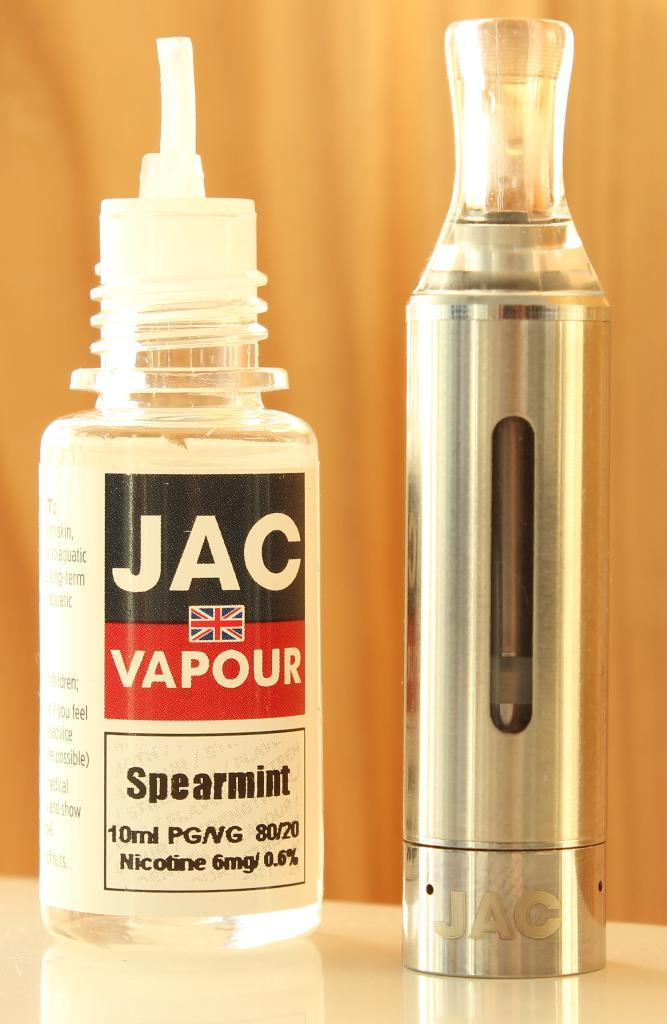<image>
Give a short and clear explanation of the subsequent image. A vaping device and a bottle of spearmin vaping liquid sit side by side. 